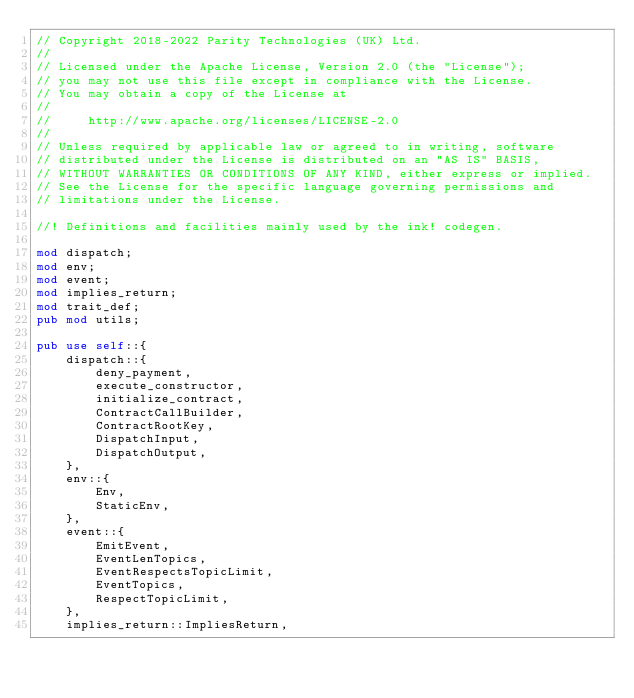Convert code to text. <code><loc_0><loc_0><loc_500><loc_500><_Rust_>// Copyright 2018-2022 Parity Technologies (UK) Ltd.
//
// Licensed under the Apache License, Version 2.0 (the "License");
// you may not use this file except in compliance with the License.
// You may obtain a copy of the License at
//
//     http://www.apache.org/licenses/LICENSE-2.0
//
// Unless required by applicable law or agreed to in writing, software
// distributed under the License is distributed on an "AS IS" BASIS,
// WITHOUT WARRANTIES OR CONDITIONS OF ANY KIND, either express or implied.
// See the License for the specific language governing permissions and
// limitations under the License.

//! Definitions and facilities mainly used by the ink! codegen.

mod dispatch;
mod env;
mod event;
mod implies_return;
mod trait_def;
pub mod utils;

pub use self::{
    dispatch::{
        deny_payment,
        execute_constructor,
        initialize_contract,
        ContractCallBuilder,
        ContractRootKey,
        DispatchInput,
        DispatchOutput,
    },
    env::{
        Env,
        StaticEnv,
    },
    event::{
        EmitEvent,
        EventLenTopics,
        EventRespectsTopicLimit,
        EventTopics,
        RespectTopicLimit,
    },
    implies_return::ImpliesReturn,</code> 